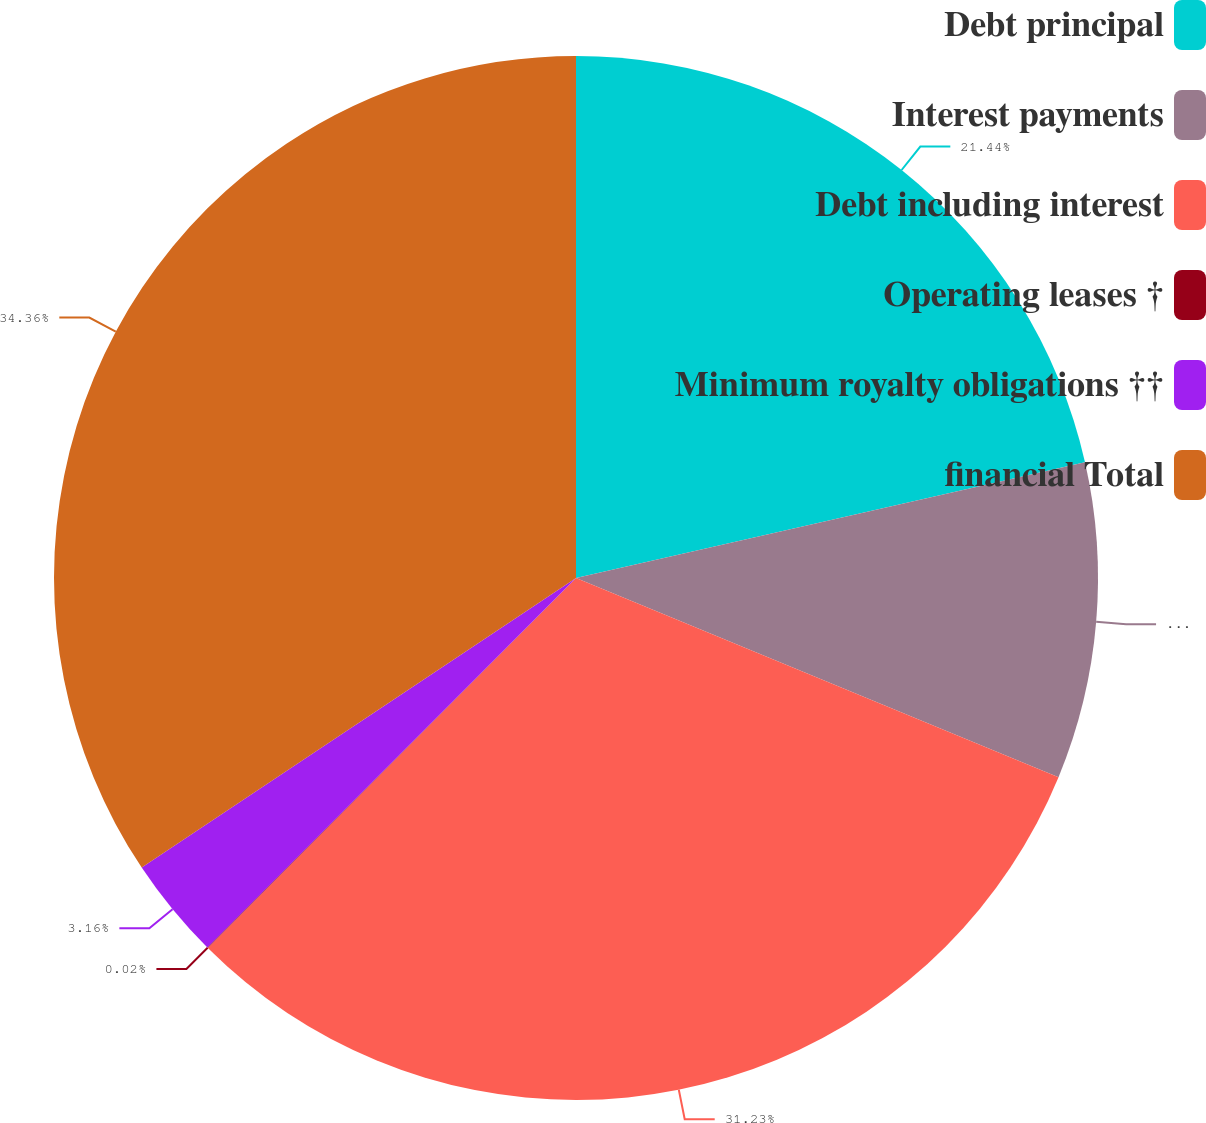Convert chart. <chart><loc_0><loc_0><loc_500><loc_500><pie_chart><fcel>Debt principal<fcel>Interest payments<fcel>Debt including interest<fcel>Operating leases †<fcel>Minimum royalty obligations ††<fcel>financial Total<nl><fcel>21.44%<fcel>9.79%<fcel>31.23%<fcel>0.02%<fcel>3.16%<fcel>34.36%<nl></chart> 